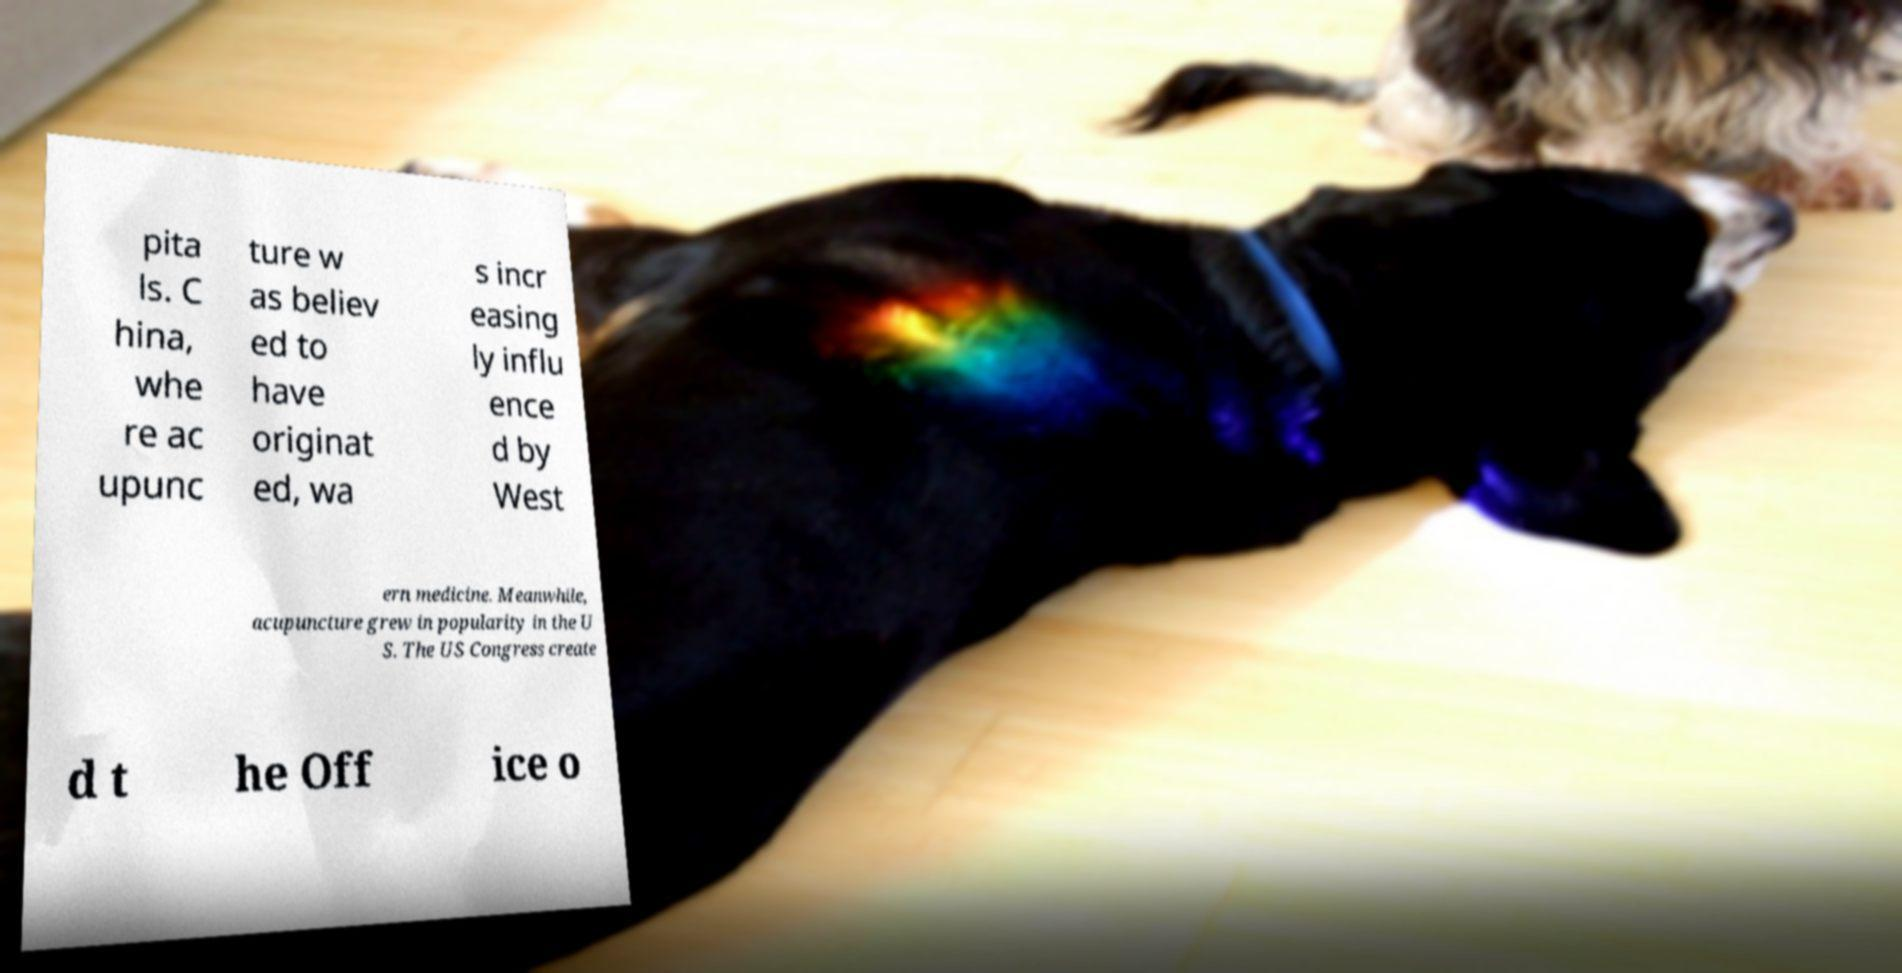For documentation purposes, I need the text within this image transcribed. Could you provide that? pita ls. C hina, whe re ac upunc ture w as believ ed to have originat ed, wa s incr easing ly influ ence d by West ern medicine. Meanwhile, acupuncture grew in popularity in the U S. The US Congress create d t he Off ice o 